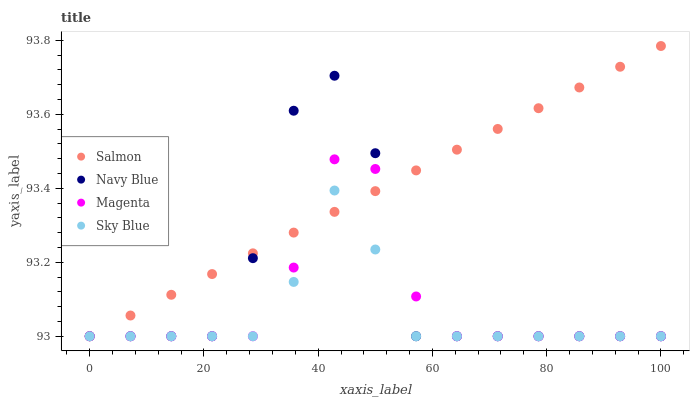Does Sky Blue have the minimum area under the curve?
Answer yes or no. Yes. Does Salmon have the maximum area under the curve?
Answer yes or no. Yes. Does Magenta have the minimum area under the curve?
Answer yes or no. No. Does Magenta have the maximum area under the curve?
Answer yes or no. No. Is Salmon the smoothest?
Answer yes or no. Yes. Is Navy Blue the roughest?
Answer yes or no. Yes. Is Magenta the smoothest?
Answer yes or no. No. Is Magenta the roughest?
Answer yes or no. No. Does Navy Blue have the lowest value?
Answer yes or no. Yes. Does Salmon have the highest value?
Answer yes or no. Yes. Does Magenta have the highest value?
Answer yes or no. No. Does Sky Blue intersect Navy Blue?
Answer yes or no. Yes. Is Sky Blue less than Navy Blue?
Answer yes or no. No. Is Sky Blue greater than Navy Blue?
Answer yes or no. No. 